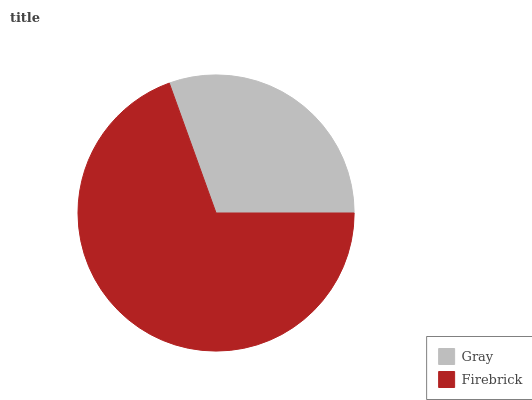Is Gray the minimum?
Answer yes or no. Yes. Is Firebrick the maximum?
Answer yes or no. Yes. Is Firebrick the minimum?
Answer yes or no. No. Is Firebrick greater than Gray?
Answer yes or no. Yes. Is Gray less than Firebrick?
Answer yes or no. Yes. Is Gray greater than Firebrick?
Answer yes or no. No. Is Firebrick less than Gray?
Answer yes or no. No. Is Firebrick the high median?
Answer yes or no. Yes. Is Gray the low median?
Answer yes or no. Yes. Is Gray the high median?
Answer yes or no. No. Is Firebrick the low median?
Answer yes or no. No. 